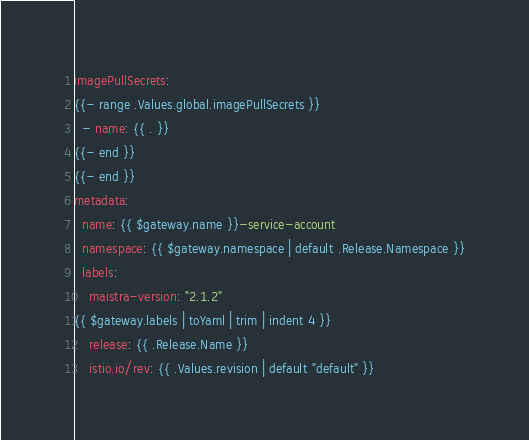<code> <loc_0><loc_0><loc_500><loc_500><_YAML_>imagePullSecrets:
{{- range .Values.global.imagePullSecrets }}
  - name: {{ . }}
{{- end }}
{{- end }}
metadata:
  name: {{ $gateway.name }}-service-account
  namespace: {{ $gateway.namespace | default .Release.Namespace }}
  labels:
    maistra-version: "2.1.2"
{{ $gateway.labels | toYaml | trim | indent 4 }}
    release: {{ .Release.Name }}
    istio.io/rev: {{ .Values.revision | default "default" }}
</code> 